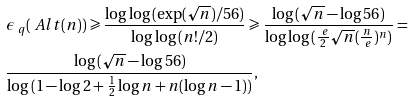Convert formula to latex. <formula><loc_0><loc_0><loc_500><loc_500>& \epsilon _ { \ q } ( \ A l t ( n ) ) \geqslant \frac { \log \log { ( \exp ( \sqrt { n } ) / 5 6 ) } } { \log \log { ( n ! / 2 ) } } \geqslant \frac { \log { ( \sqrt { n } - \log { 5 6 } ) } } { \log \log { ( \frac { \ e } { 2 } \sqrt { n } ( \frac { n } { \ e } ) ^ { n } ) } } = \\ & \frac { \log { ( \sqrt { n } - \log { 5 6 } ) } } { \log { ( 1 - \log { 2 } + \frac { 1 } { 2 } \log { n } + n ( \log { n } - 1 ) ) } } ,</formula> 